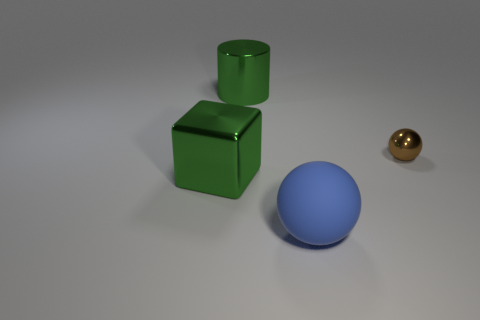Add 1 large blue rubber objects. How many objects exist? 5 Subtract all blue spheres. How many red cubes are left? 0 Subtract all large blue matte cubes. Subtract all green shiny things. How many objects are left? 2 Add 4 green metallic things. How many green metallic things are left? 6 Add 2 tiny shiny objects. How many tiny shiny objects exist? 3 Subtract 0 brown cylinders. How many objects are left? 4 Subtract 1 cylinders. How many cylinders are left? 0 Subtract all cyan blocks. Subtract all green balls. How many blocks are left? 1 